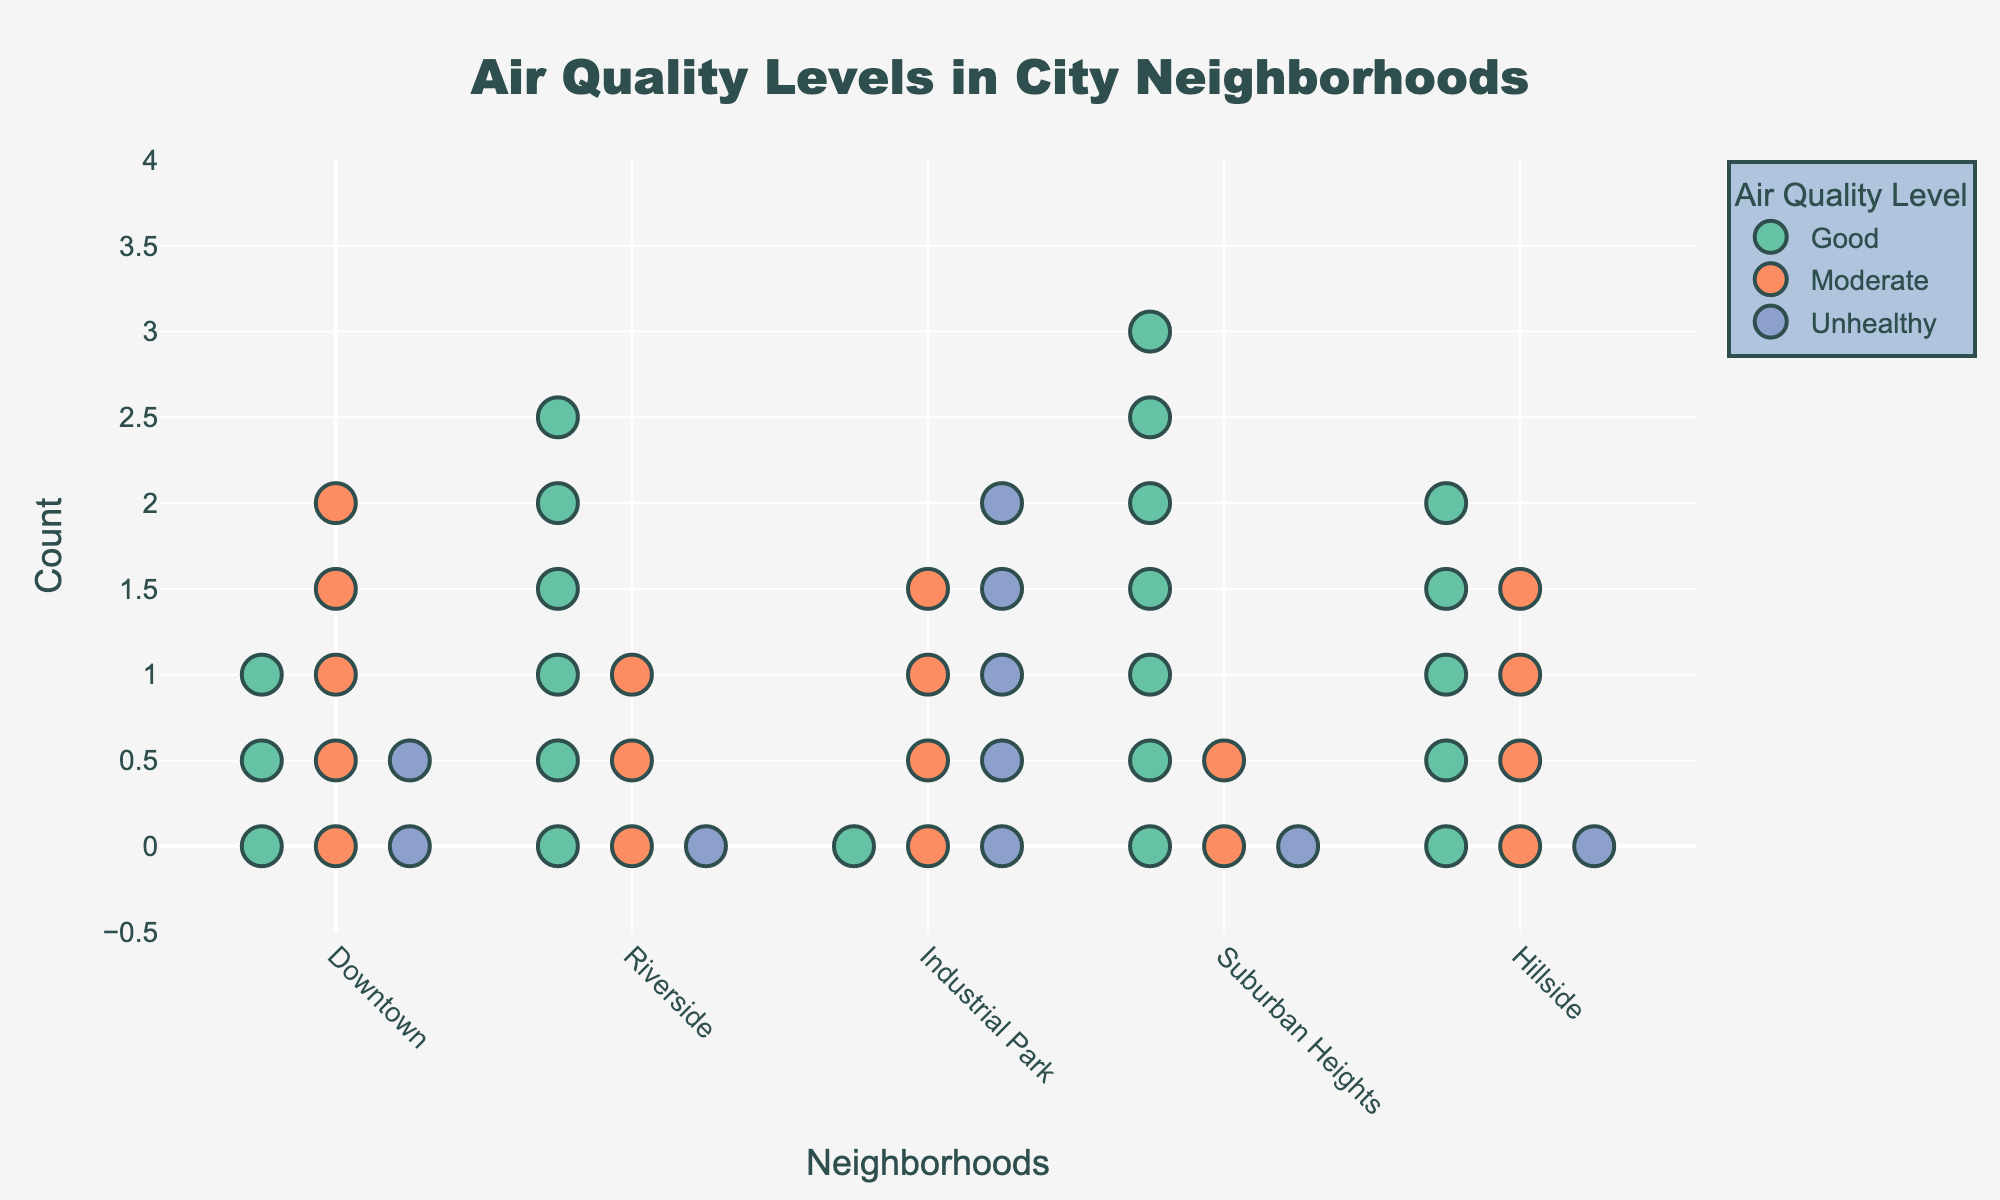What are the neighborhoods compared in the plot? The x-axis labels of the plot represent the neighborhoods compared in the figure. They are Downtown, Riverside, Industrial Park, Suburban Heights, and Hillside.
Answer: Downtown, Riverside, Industrial Park, Suburban Heights, Hillside How many data points reflect “Good” air quality in Downtown? In the plot, each marker represents one count of a specific air quality level. There are 3 markers for “Good” air quality in Downtown.
Answer: 3 Which neighborhood has the highest count of “Moderate” air quality levels? By observing the number of markers in the "Moderate" color for each neighborhood, Riverside has the highest count with 4 markers.
Answer: Riverside What's the total count of “Unhealthy” air quality markers for Industrial Park? Counting the markers for “Unhealthy” air quality in Industrial Park totals up to 5 markers.
Answer: 5 Is the count of “Good” air quality higher in Suburban Heights or Riverside? Suburban Heights has 7 markers for “Good” air quality, whereas Riverside has 6. Therefore, Suburban Heights has a higher count.
Answer: Suburban Heights How does the distribution of air quality in Hillside compare to Downtown? For Hillside, the counts for "Good", "Moderate", and "Unhealthy" are 5, 4, and 1, respectively. For Downtown, the counts are 3, 5, and 2. Hillside has more "Good" air quality markers, Downtown has more "Moderate", and Downtown also has more "Unhealthy" markers.
Answer: Hillside: more "Good"; Downtown: more "Moderate" and "Unhealthy" What percentage of Downtown’s air quality markers are “Unhealthy”? Downtown has a total of 10 markers (3 "Good", 5 "Moderate", 2 "Unhealthy"). The percentage of "Unhealthy" markers is calculated as (2/10) * 100 = 20%.
Answer: 20% Which neighborhood has the lowest total count of air quality markers? By summing up the counts for each neighborhood and comparing them, Industrial Park has the lowest total count with 10 markers: 1 "Good", 4 "Moderate", and 5 "Unhealthy".
Answer: Industrial Park What's the combined count of “Moderate” air quality markers in all neighborhoods? Adding up all the "Moderate" markers across neighborhoods gives 5 (Downtown) + 3 (Riverside) + 4 (Industrial Park) + 2 (Suburban Heights) + 4 (Hillside) = 18.
Answer: 18 